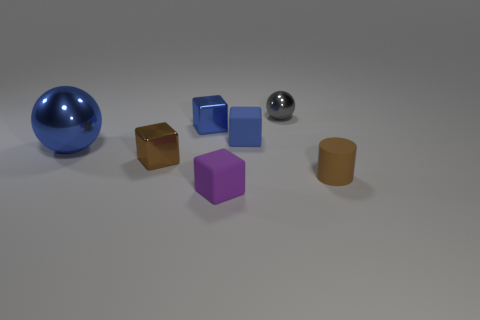Add 1 small green matte cylinders. How many objects exist? 8 Subtract all spheres. How many objects are left? 5 Subtract 1 brown cylinders. How many objects are left? 6 Subtract all large red rubber balls. Subtract all small cylinders. How many objects are left? 6 Add 7 purple things. How many purple things are left? 8 Add 1 brown blocks. How many brown blocks exist? 2 